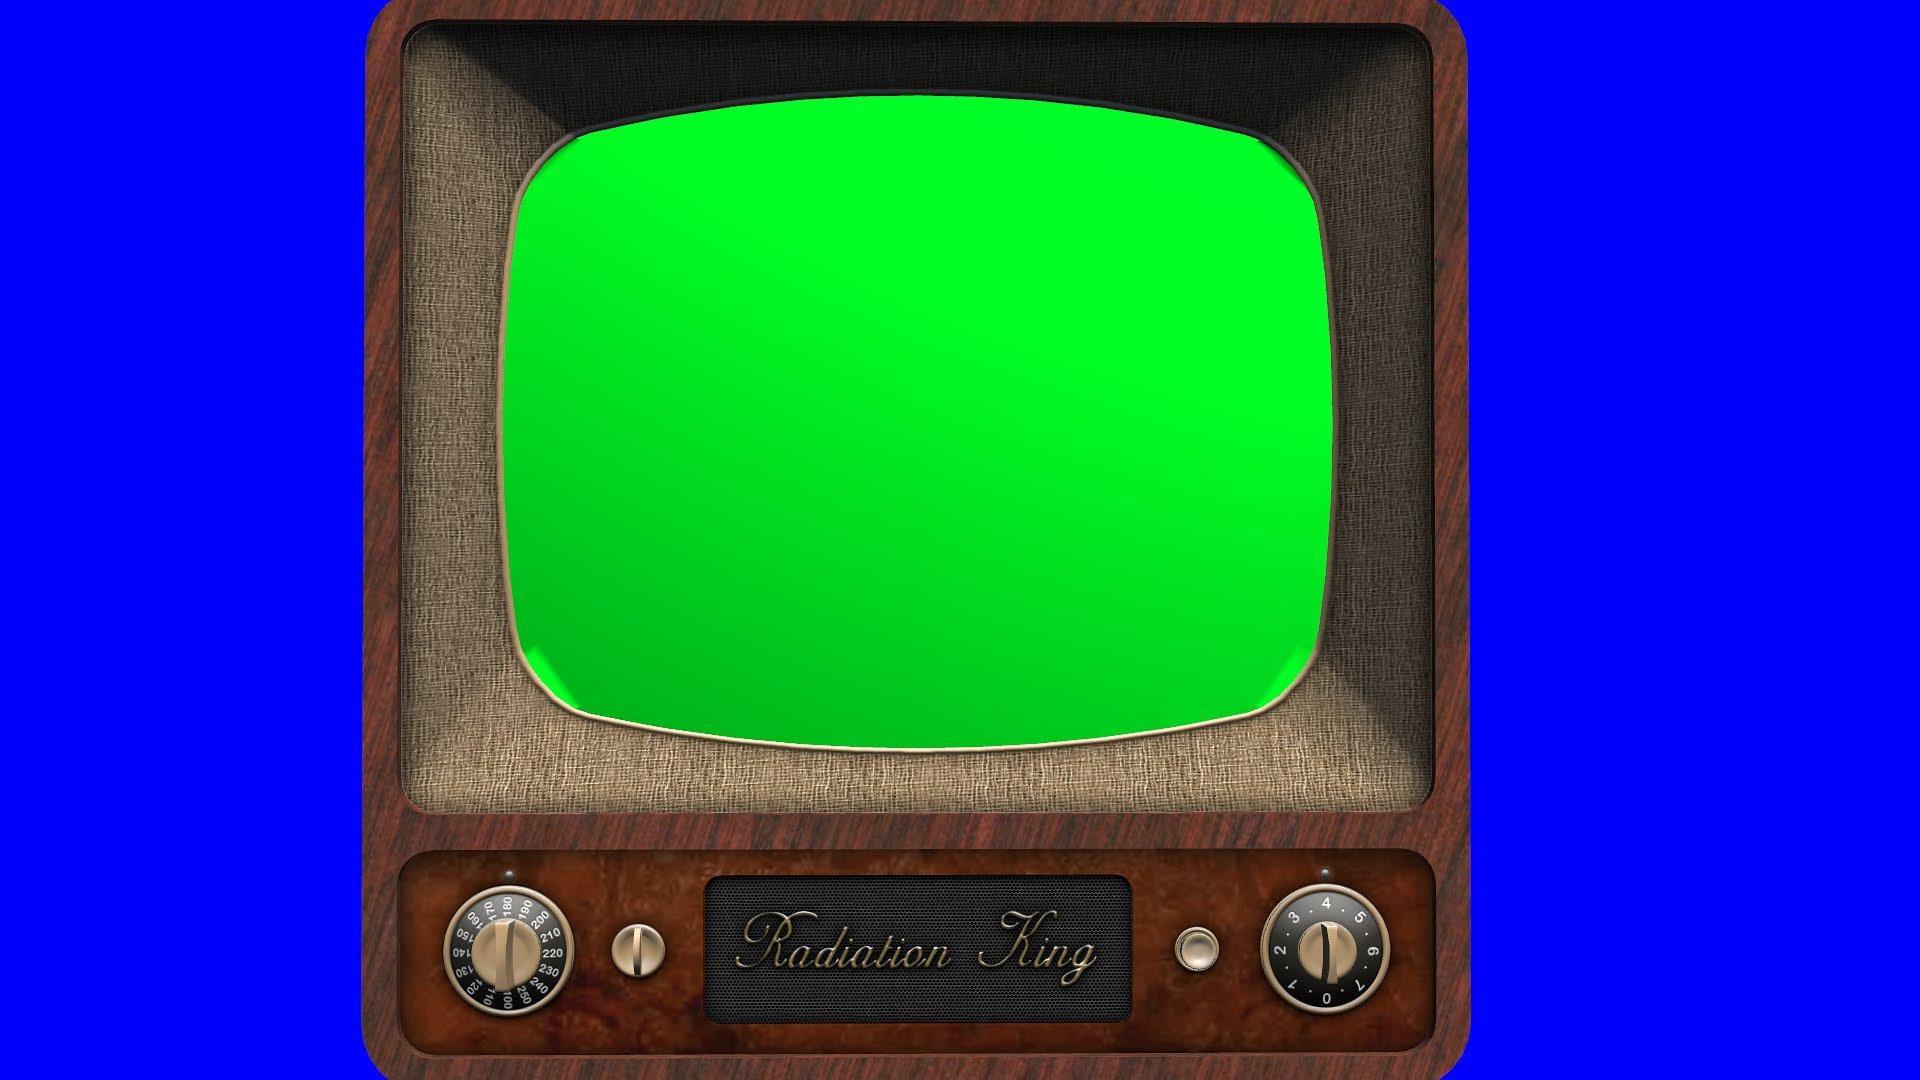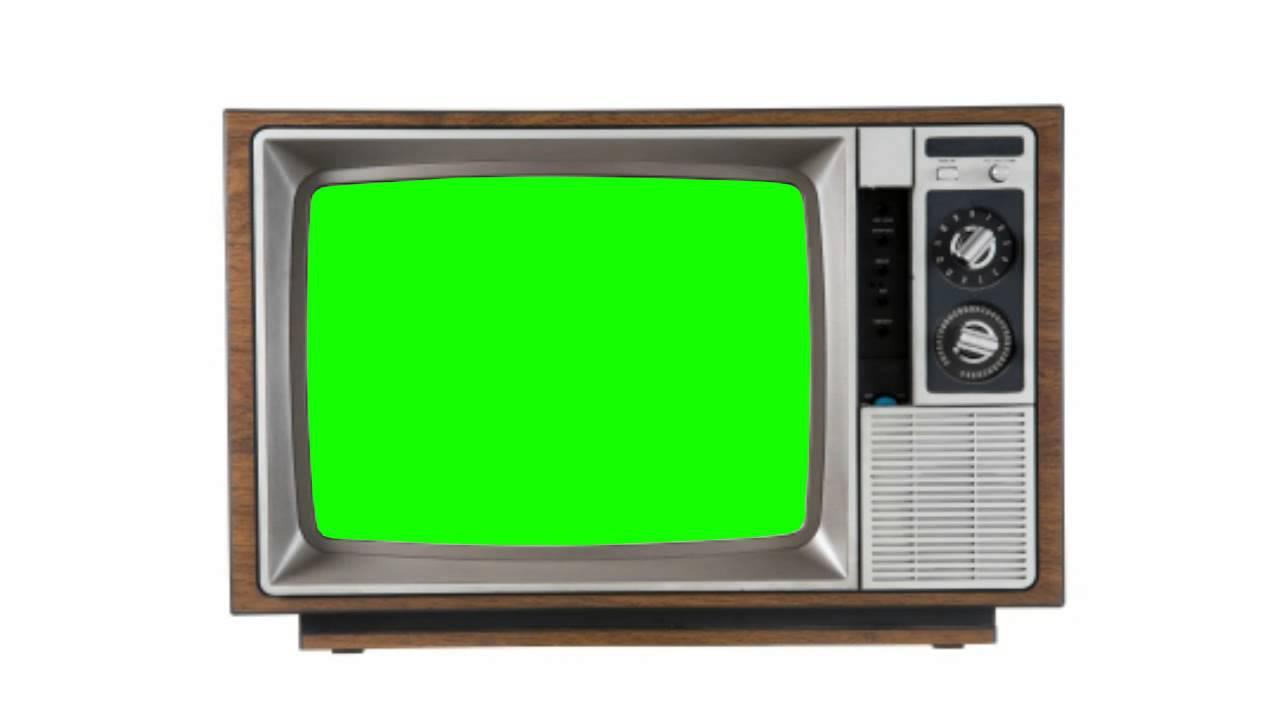The first image is the image on the left, the second image is the image on the right. Given the left and right images, does the statement "A single television with a bright green screen has a blue background." hold true? Answer yes or no. Yes. The first image is the image on the left, the second image is the image on the right. For the images shown, is this caption "One glowing green TV screen is modern, flat and wide, and the other glowing green screen is in an old-fashioned box-like TV set." true? Answer yes or no. No. 